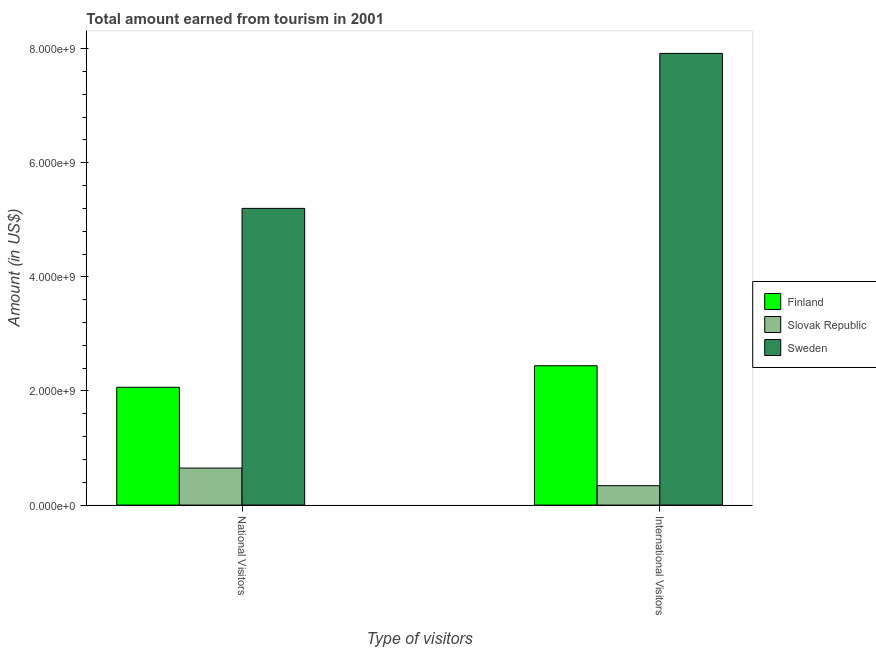Are the number of bars per tick equal to the number of legend labels?
Your response must be concise. Yes. How many bars are there on the 2nd tick from the right?
Keep it short and to the point. 3. What is the label of the 2nd group of bars from the left?
Provide a succinct answer. International Visitors. What is the amount earned from international visitors in Slovak Republic?
Provide a succinct answer. 3.40e+08. Across all countries, what is the maximum amount earned from national visitors?
Ensure brevity in your answer.  5.20e+09. Across all countries, what is the minimum amount earned from international visitors?
Make the answer very short. 3.40e+08. In which country was the amount earned from international visitors maximum?
Ensure brevity in your answer.  Sweden. In which country was the amount earned from national visitors minimum?
Make the answer very short. Slovak Republic. What is the total amount earned from national visitors in the graph?
Your answer should be compact. 7.91e+09. What is the difference between the amount earned from international visitors in Finland and that in Sweden?
Provide a short and direct response. -5.47e+09. What is the difference between the amount earned from national visitors in Finland and the amount earned from international visitors in Sweden?
Your answer should be very brief. -5.85e+09. What is the average amount earned from national visitors per country?
Your answer should be compact. 2.64e+09. What is the difference between the amount earned from national visitors and amount earned from international visitors in Sweden?
Keep it short and to the point. -2.72e+09. In how many countries, is the amount earned from national visitors greater than 4800000000 US$?
Your answer should be very brief. 1. What is the ratio of the amount earned from national visitors in Slovak Republic to that in Finland?
Your answer should be very brief. 0.31. In how many countries, is the amount earned from national visitors greater than the average amount earned from national visitors taken over all countries?
Your answer should be very brief. 1. What does the 3rd bar from the left in International Visitors represents?
Provide a succinct answer. Sweden. How many bars are there?
Keep it short and to the point. 6. What is the difference between two consecutive major ticks on the Y-axis?
Your answer should be very brief. 2.00e+09. Does the graph contain any zero values?
Provide a succinct answer. No. Does the graph contain grids?
Provide a short and direct response. No. Where does the legend appear in the graph?
Keep it short and to the point. Center right. What is the title of the graph?
Offer a terse response. Total amount earned from tourism in 2001. Does "India" appear as one of the legend labels in the graph?
Give a very brief answer. No. What is the label or title of the X-axis?
Keep it short and to the point. Type of visitors. What is the Amount (in US$) of Finland in National Visitors?
Ensure brevity in your answer.  2.06e+09. What is the Amount (in US$) of Slovak Republic in National Visitors?
Keep it short and to the point. 6.49e+08. What is the Amount (in US$) of Sweden in National Visitors?
Your response must be concise. 5.20e+09. What is the Amount (in US$) of Finland in International Visitors?
Your answer should be very brief. 2.44e+09. What is the Amount (in US$) in Slovak Republic in International Visitors?
Provide a short and direct response. 3.40e+08. What is the Amount (in US$) in Sweden in International Visitors?
Provide a succinct answer. 7.92e+09. Across all Type of visitors, what is the maximum Amount (in US$) of Finland?
Keep it short and to the point. 2.44e+09. Across all Type of visitors, what is the maximum Amount (in US$) of Slovak Republic?
Offer a terse response. 6.49e+08. Across all Type of visitors, what is the maximum Amount (in US$) in Sweden?
Offer a terse response. 7.92e+09. Across all Type of visitors, what is the minimum Amount (in US$) in Finland?
Your response must be concise. 2.06e+09. Across all Type of visitors, what is the minimum Amount (in US$) of Slovak Republic?
Keep it short and to the point. 3.40e+08. Across all Type of visitors, what is the minimum Amount (in US$) of Sweden?
Give a very brief answer. 5.20e+09. What is the total Amount (in US$) in Finland in the graph?
Offer a terse response. 4.51e+09. What is the total Amount (in US$) in Slovak Republic in the graph?
Offer a very short reply. 9.89e+08. What is the total Amount (in US$) of Sweden in the graph?
Give a very brief answer. 1.31e+1. What is the difference between the Amount (in US$) in Finland in National Visitors and that in International Visitors?
Provide a short and direct response. -3.77e+08. What is the difference between the Amount (in US$) in Slovak Republic in National Visitors and that in International Visitors?
Your answer should be very brief. 3.09e+08. What is the difference between the Amount (in US$) of Sweden in National Visitors and that in International Visitors?
Ensure brevity in your answer.  -2.72e+09. What is the difference between the Amount (in US$) in Finland in National Visitors and the Amount (in US$) in Slovak Republic in International Visitors?
Your answer should be compact. 1.72e+09. What is the difference between the Amount (in US$) of Finland in National Visitors and the Amount (in US$) of Sweden in International Visitors?
Offer a very short reply. -5.85e+09. What is the difference between the Amount (in US$) of Slovak Republic in National Visitors and the Amount (in US$) of Sweden in International Visitors?
Provide a succinct answer. -7.27e+09. What is the average Amount (in US$) of Finland per Type of visitors?
Provide a succinct answer. 2.25e+09. What is the average Amount (in US$) of Slovak Republic per Type of visitors?
Your answer should be compact. 4.94e+08. What is the average Amount (in US$) in Sweden per Type of visitors?
Keep it short and to the point. 6.56e+09. What is the difference between the Amount (in US$) in Finland and Amount (in US$) in Slovak Republic in National Visitors?
Your answer should be compact. 1.42e+09. What is the difference between the Amount (in US$) in Finland and Amount (in US$) in Sweden in National Visitors?
Give a very brief answer. -3.14e+09. What is the difference between the Amount (in US$) of Slovak Republic and Amount (in US$) of Sweden in National Visitors?
Your answer should be very brief. -4.55e+09. What is the difference between the Amount (in US$) of Finland and Amount (in US$) of Slovak Republic in International Visitors?
Give a very brief answer. 2.10e+09. What is the difference between the Amount (in US$) of Finland and Amount (in US$) of Sweden in International Visitors?
Offer a terse response. -5.47e+09. What is the difference between the Amount (in US$) of Slovak Republic and Amount (in US$) of Sweden in International Visitors?
Keep it short and to the point. -7.58e+09. What is the ratio of the Amount (in US$) in Finland in National Visitors to that in International Visitors?
Your answer should be compact. 0.85. What is the ratio of the Amount (in US$) in Slovak Republic in National Visitors to that in International Visitors?
Make the answer very short. 1.91. What is the ratio of the Amount (in US$) of Sweden in National Visitors to that in International Visitors?
Your answer should be very brief. 0.66. What is the difference between the highest and the second highest Amount (in US$) in Finland?
Your answer should be compact. 3.77e+08. What is the difference between the highest and the second highest Amount (in US$) in Slovak Republic?
Offer a terse response. 3.09e+08. What is the difference between the highest and the second highest Amount (in US$) in Sweden?
Offer a very short reply. 2.72e+09. What is the difference between the highest and the lowest Amount (in US$) in Finland?
Your answer should be compact. 3.77e+08. What is the difference between the highest and the lowest Amount (in US$) in Slovak Republic?
Keep it short and to the point. 3.09e+08. What is the difference between the highest and the lowest Amount (in US$) of Sweden?
Your answer should be very brief. 2.72e+09. 